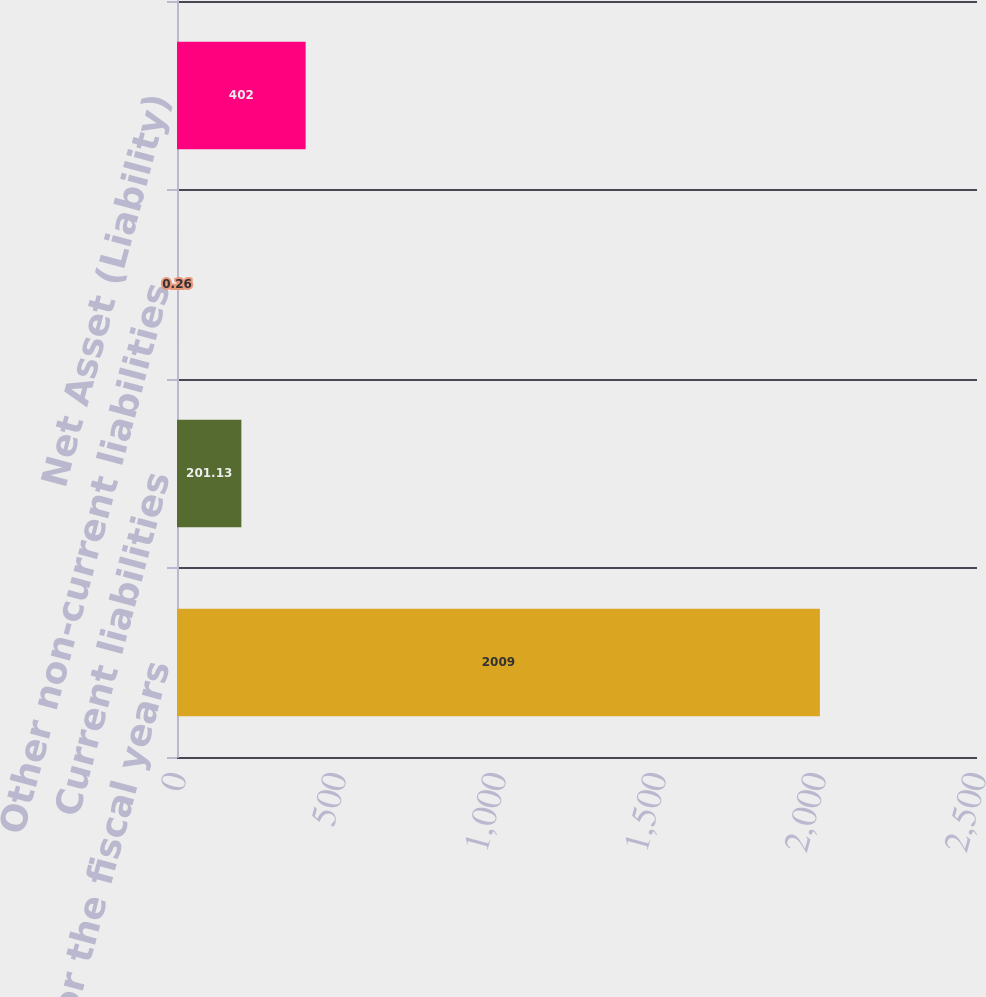Convert chart to OTSL. <chart><loc_0><loc_0><loc_500><loc_500><bar_chart><fcel>as of and for the fiscal years<fcel>Current liabilities<fcel>Other non-current liabilities<fcel>Net Asset (Liability)<nl><fcel>2009<fcel>201.13<fcel>0.26<fcel>402<nl></chart> 